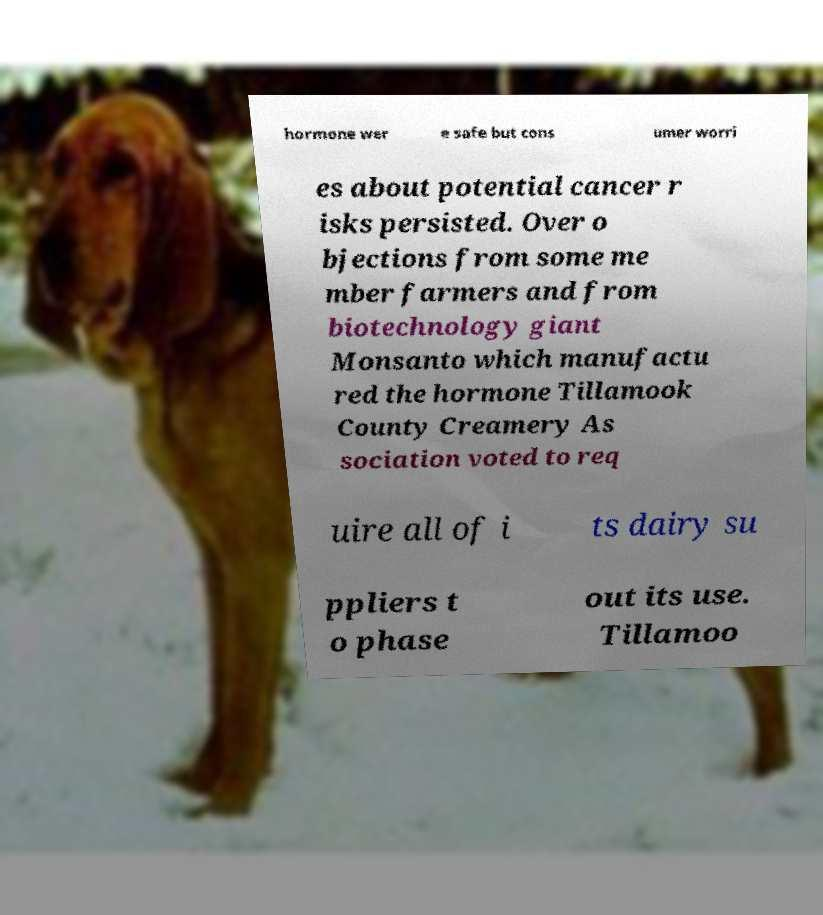For documentation purposes, I need the text within this image transcribed. Could you provide that? hormone wer e safe but cons umer worri es about potential cancer r isks persisted. Over o bjections from some me mber farmers and from biotechnology giant Monsanto which manufactu red the hormone Tillamook County Creamery As sociation voted to req uire all of i ts dairy su ppliers t o phase out its use. Tillamoo 